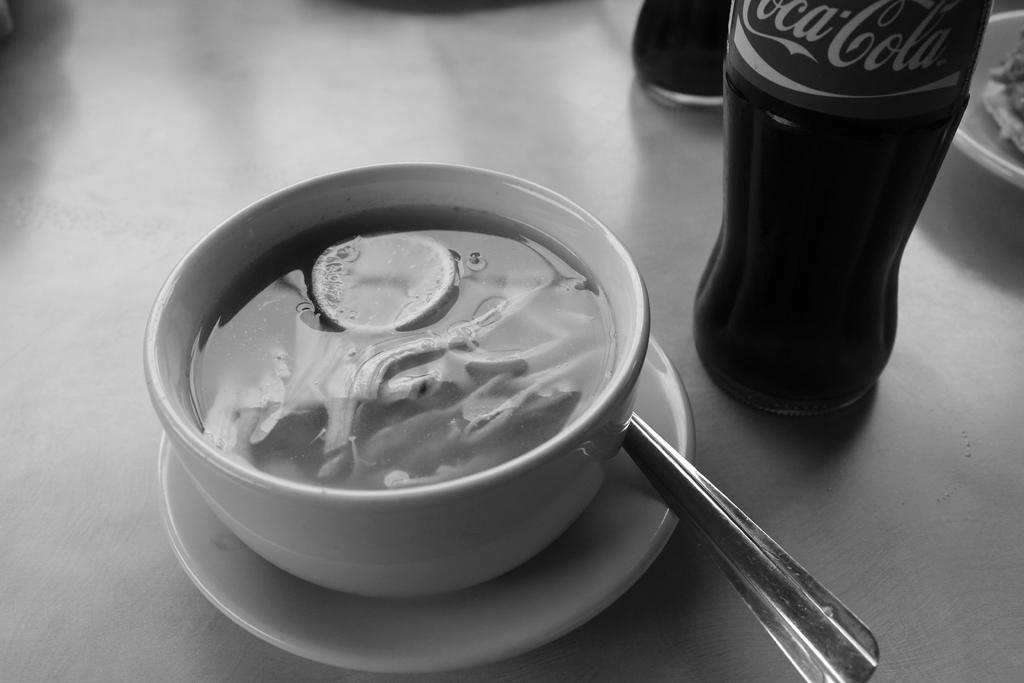What drink are they pairing with this soup?
Provide a short and direct response. Coca cola. 